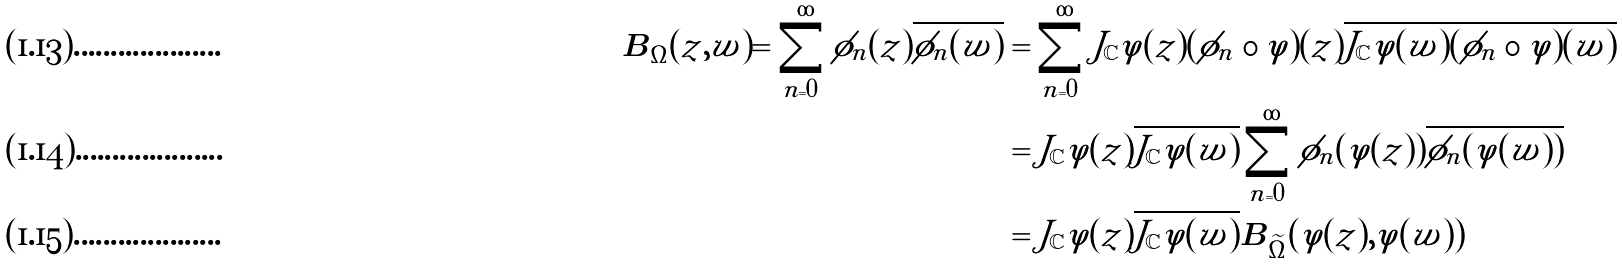<formula> <loc_0><loc_0><loc_500><loc_500>\boldsymbol B _ { \Omega } ( z , w ) = \sum _ { n = 0 } ^ { \infty } \phi _ { n } ( z ) \overline { \phi _ { n } ( w ) } & = \sum _ { n = 0 } ^ { \infty } J _ { \mathbb { C } } \varphi ( z ) ( \tilde { \phi } _ { n } \circ \varphi ) ( z ) \overline { J _ { \mathbb { C } } \varphi ( w ) ( \tilde { \phi } _ { n } \circ \varphi ) ( w ) } \\ & = J _ { \mathbb { C } } \varphi ( z ) \overline { J _ { \mathbb { C } } \varphi ( w ) } \sum _ { n = 0 } ^ { \infty } \tilde { \phi } _ { n } ( \varphi ( z ) ) \overline { \tilde { \phi } _ { n } ( \varphi ( w ) ) } \\ & = J _ { \mathbb { C } } \varphi ( z ) \overline { J _ { \mathbb { C } } \varphi ( w ) } \boldsymbol B _ { \widetilde { \Omega } } ( \varphi ( z ) , \varphi ( w ) )</formula> 